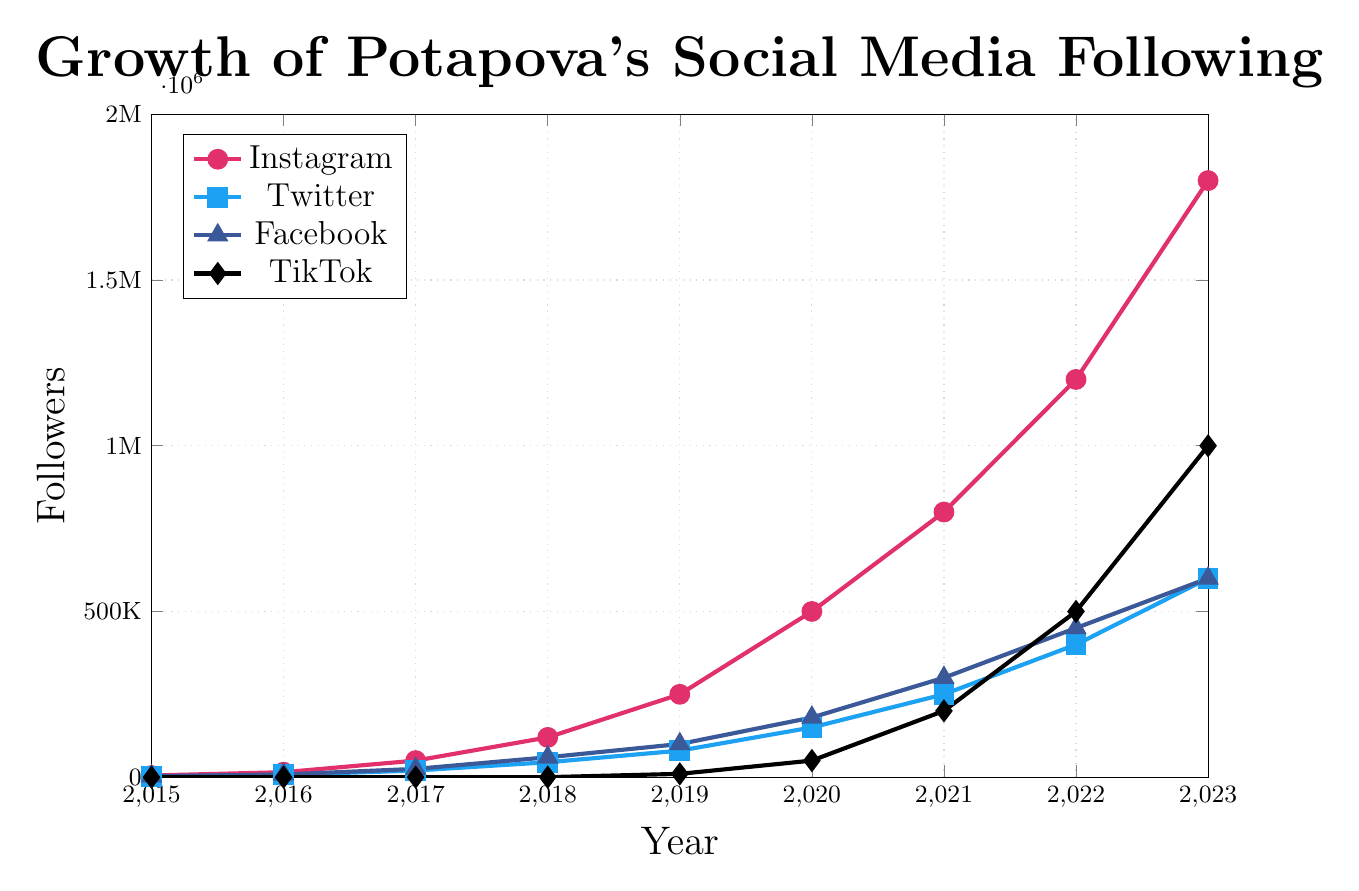What's the overall trend of Potapova's Instagram followers from 2015 to 2023? From 2015 to 2023, the graph illustrates a steady rise in Instagram followers. This trend is visually represented by a consistently upward-sloping line, showing an increase from 5,000 followers in 2015 to 1,800,000 followers in 2023.
Answer: Upward trend Which platform had the fastest growth in followers between 2019 and 2023? By examining the steepness of the lines between 2019 and 2023, TikTok shows the fastest growth. The slope of TikTok's line is very steep compared to other platforms, growing from 10,000 in 2019 to 1,000,000 in 2023.
Answer: TikTok In what year did Potapova's Twitter followers first reach 100,000? Tracing the Twitter data points along the timeline, Potapova's Twitter followers reached 100,000 between 2018 and 2019 when it was about 80,000 and then grew to 150,000 in 2020. Therefore, it reached 100,000 in 2019.
Answer: 2019 What is the difference in followers between Instagram and Facebook in 2023? In 2023, Instagram followers are 1,800,000, and Facebook followers are 600,000. The difference is calculated as 1,800,000 - 600,000.
Answer: 1,200,000 On which platform did Potapova have the least growth in followers by 2023? Observing the total increase in followers from 2015 to 2023, Twitter grew from 2,000 to 600,000, whereas the growth on Instagram and TikTok was more substantial. Therefore, Twitter experienced the least growth.
Answer: Twitter Compare the number of followers on Facebook and TikTok in 2020. In 2020, Facebook had 180,000 followers as indicated by the triangle markers, while TikTok had 50,000 followers as represented by the diamond markers. Comparing these values shows that Facebook had more followers than TikTok in 2020.
Answer: Facebook What is the average number of followers for Instagram from 2015 to 2017? Adding the Instagram followers from 2015 (5,000), 2016 (15,000), and 2017 (50,000) gives 70,000 followers. Dividing by the three years provides the average: 70,000/3.
Answer: 23,333 How much more growth did Instagram have from 2020 to 2023 compared to Twitter in the same period? Instagram grew from 500,000 in 2020 to 1,800,000 in 2023 (growth of 1,300,000). Twitter grew from 150,000 to 600,000 (growth of 450,000). To find the additional growth of Instagram: 1,300,000 - 450,000.
Answer: 850,000 